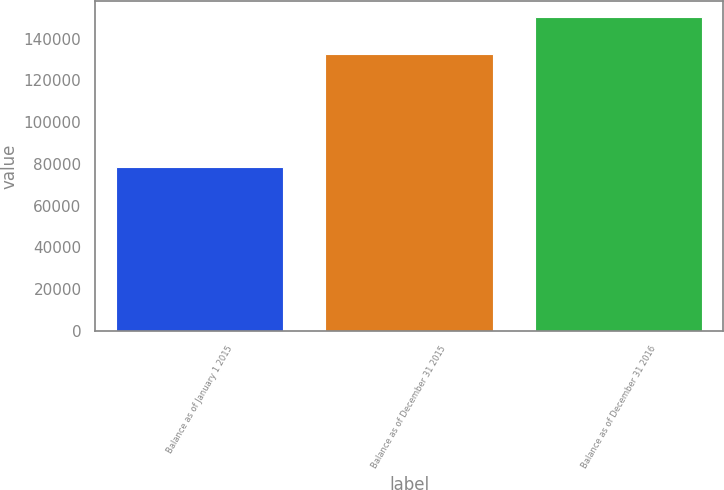Convert chart. <chart><loc_0><loc_0><loc_500><loc_500><bar_chart><fcel>Balance as of January 1 2015<fcel>Balance as of December 31 2015<fcel>Balance as of December 31 2016<nl><fcel>78647<fcel>132570<fcel>150511<nl></chart> 